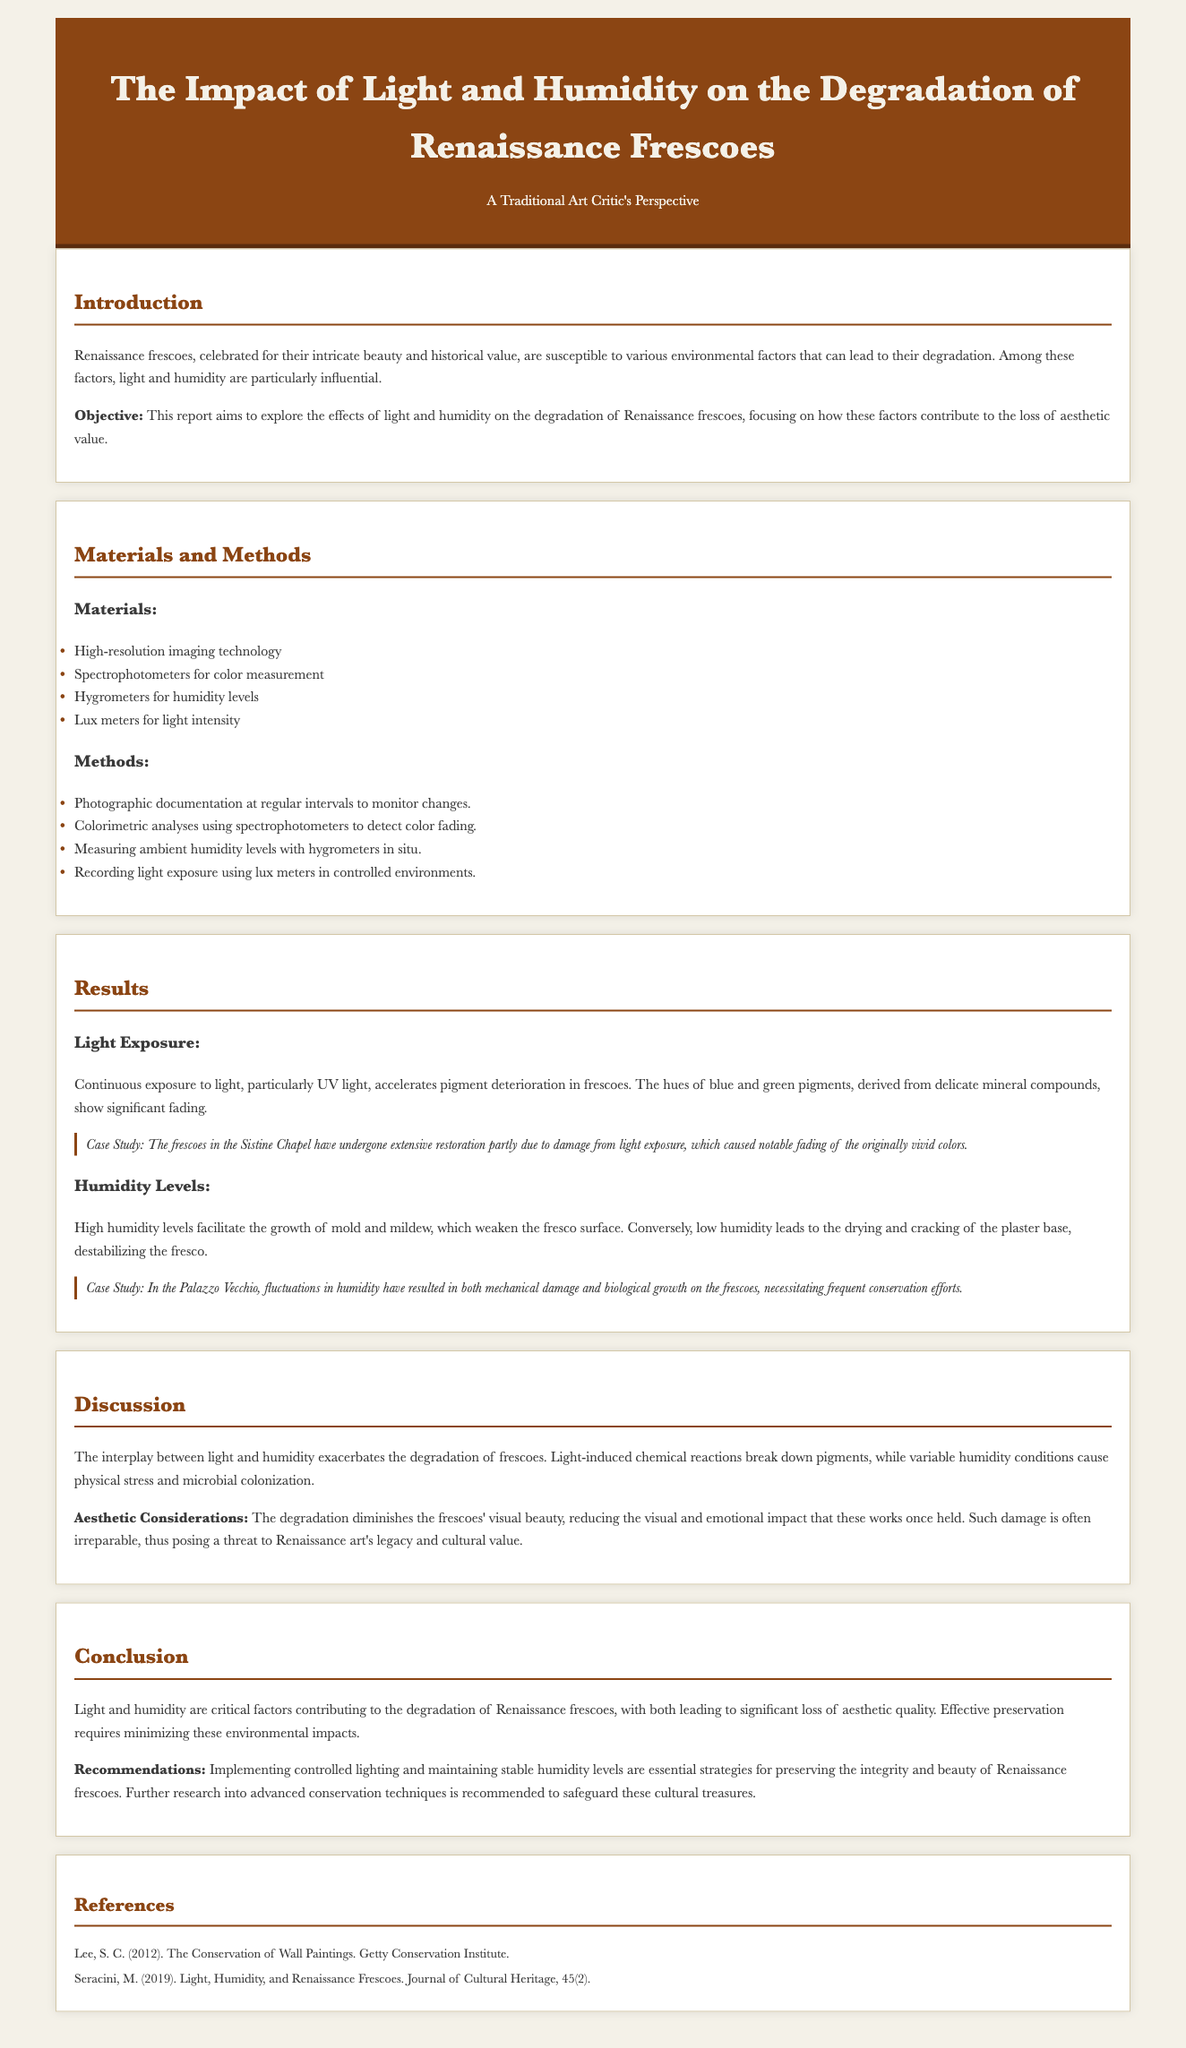What is the focus of the report? The report aims to explore the effects of light and humidity on the degradation of Renaissance frescoes.
Answer: effects of light and humidity What materials were used in the study? The materials list includes high-resolution imaging technology, spectrophotometers, hygrometers, and lux meters.
Answer: High-resolution imaging technology, spectrophotometers, hygrometers, lux meters Which pigments are mentioned as particularly affected by light? The hues of blue and green pigments are specifically mentioned as showing significant fading.
Answer: blue and green pigments What is the main consequence of high humidity on frescoes? High humidity facilitates the growth of mold and mildew, which weaken the fresco surface.
Answer: growth of mold and mildew According to the lab report, what should be implemented to preserve frescoes? The report recommends implementing controlled lighting and maintaining stable humidity levels.
Answer: controlled lighting and stable humidity levels What is a critical aesthetic consideration mentioned? The degradation diminishes the frescoes' visual beauty and reduces their visual and emotional impact.
Answer: reduces visual and emotional impact What case study is referenced regarding light damage? The frescoes in the Sistine Chapel are mentioned as having undergone extensive restoration due to light exposure damage.
Answer: Sistine Chapel What type of report is this document? This document is categorized as a lab report focusing on the degradation of art.
Answer: lab report 